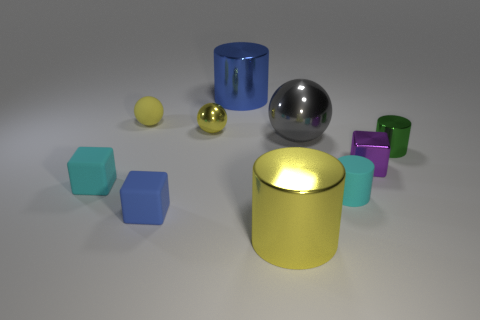There is a thing that is left of the yellow rubber ball; what shape is it?
Ensure brevity in your answer.  Cube. There is a large cylinder in front of the cyan rubber cube; does it have the same color as the small rubber ball?
Provide a short and direct response. Yes. Is the number of tiny metallic objects that are behind the green metallic cylinder less than the number of big yellow cylinders?
Give a very brief answer. No. What color is the sphere that is made of the same material as the tiny cyan cylinder?
Your response must be concise. Yellow. How big is the sphere right of the big blue metallic cylinder?
Ensure brevity in your answer.  Large. Is the material of the purple cube the same as the green object?
Keep it short and to the point. Yes. Are there any tiny yellow rubber spheres that are on the right side of the green shiny object that is behind the big thing that is in front of the tiny blue rubber block?
Provide a succinct answer. No. What is the color of the big shiny sphere?
Make the answer very short. Gray. There is a rubber ball that is the same size as the blue block; what is its color?
Give a very brief answer. Yellow. Do the blue thing that is in front of the tiny green metal object and the big blue object have the same shape?
Keep it short and to the point. No. 